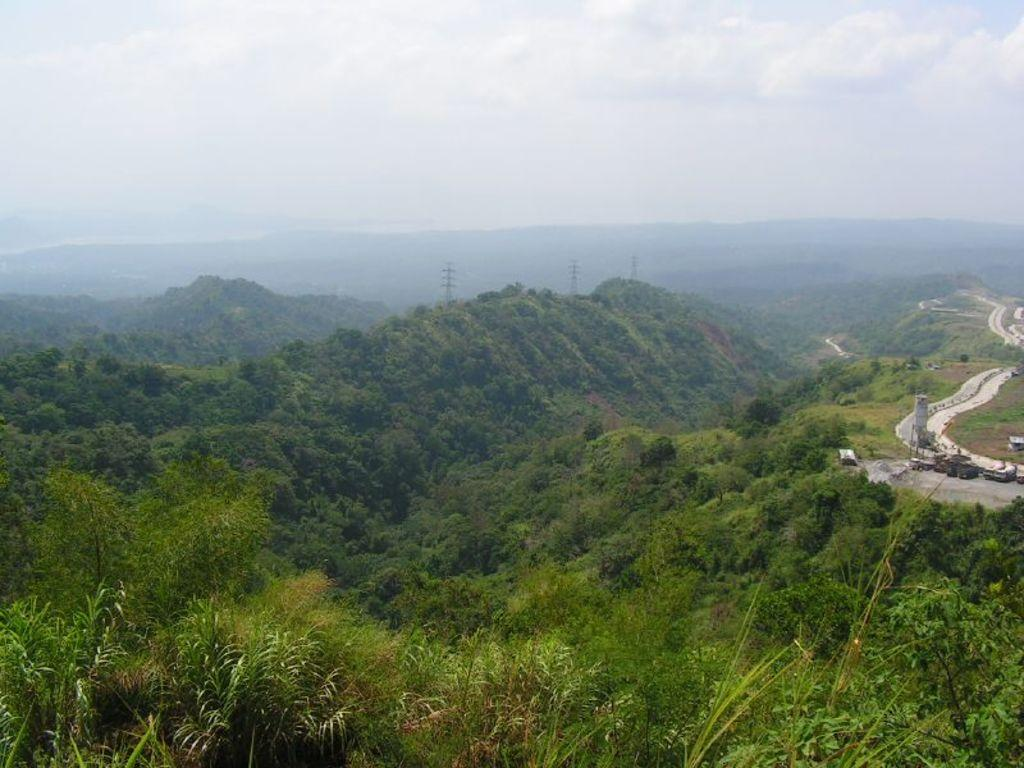What type of natural landform can be seen in the image? There are mountains in the image. What other natural elements are present in the image? There are trees and plants in the image. Can you describe the path visible in the image? Yes, there is a path visible in the image. What is visible in the background of the image? The sky is visible in the background of the image. How many rabbits can be seen hopping along the path in the image? There are no rabbits present in the image. What type of birds are flying in the sky in the image? There are no birds visible in the image; only the sky is visible in the background. 